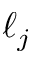<formula> <loc_0><loc_0><loc_500><loc_500>\ell _ { j }</formula> 